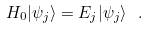Convert formula to latex. <formula><loc_0><loc_0><loc_500><loc_500>H _ { 0 } | \psi _ { j } \rangle = E _ { j } | \psi _ { j } \rangle \ .</formula> 